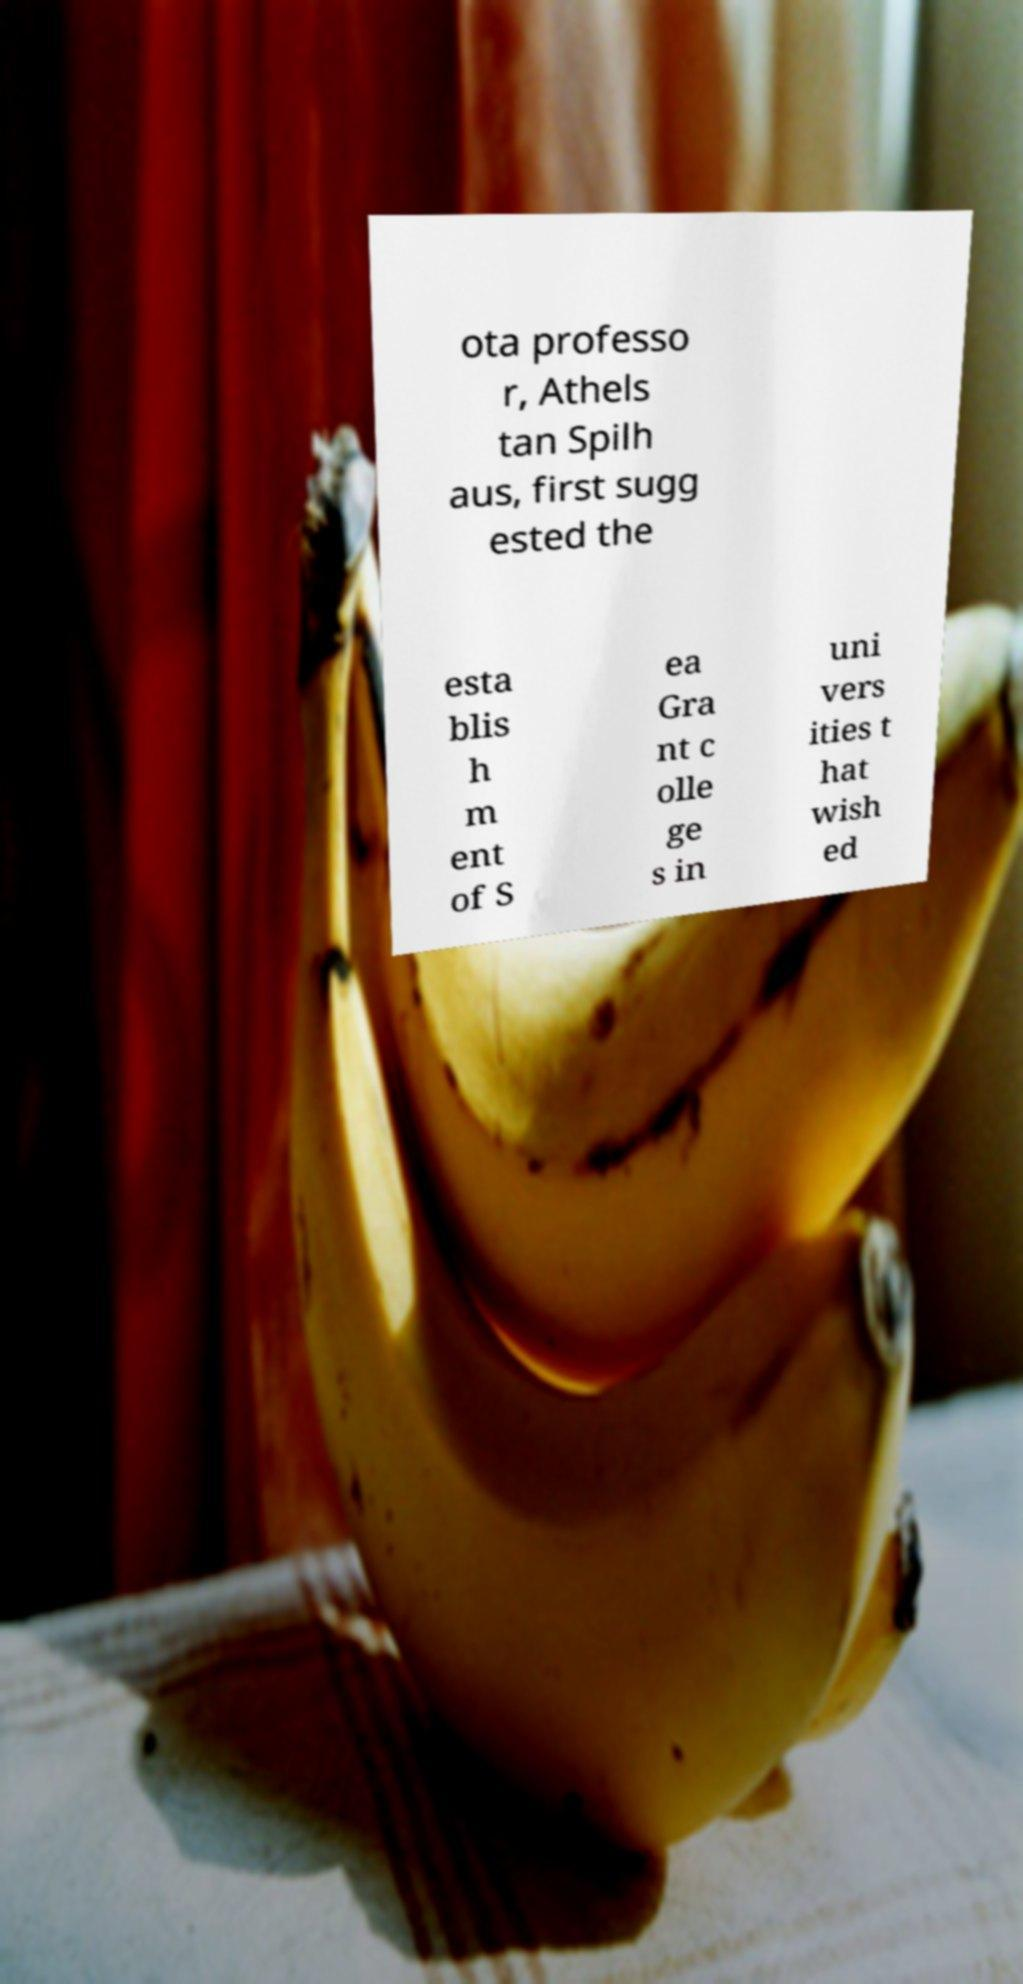For documentation purposes, I need the text within this image transcribed. Could you provide that? ota professo r, Athels tan Spilh aus, first sugg ested the esta blis h m ent of S ea Gra nt c olle ge s in uni vers ities t hat wish ed 